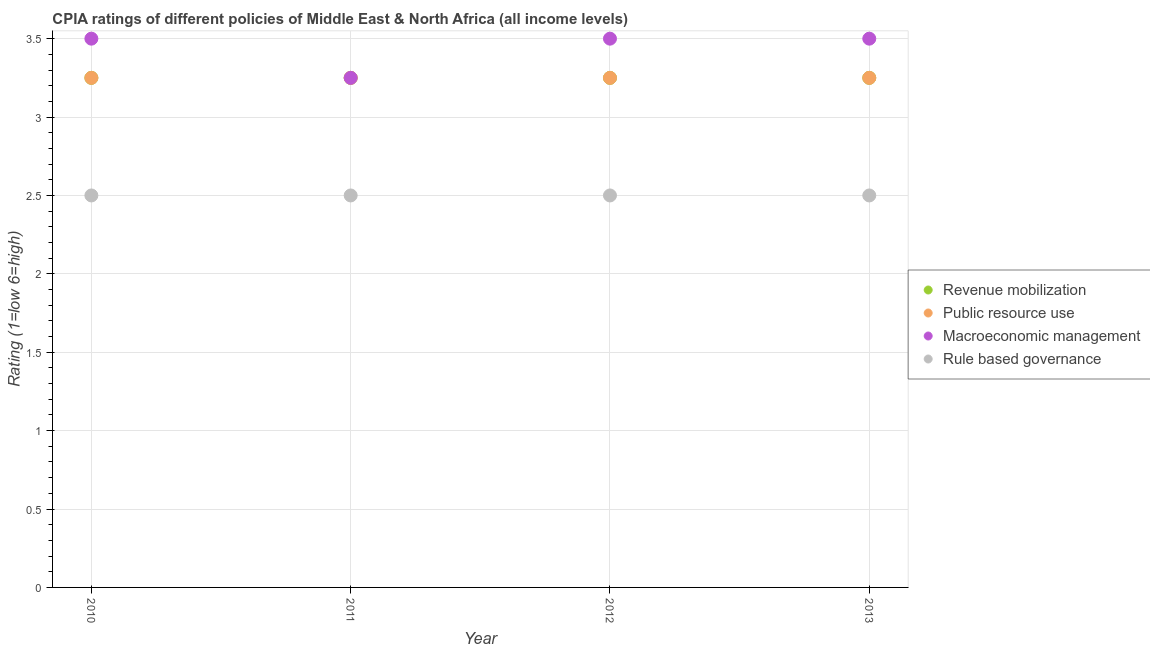Is the number of dotlines equal to the number of legend labels?
Offer a very short reply. Yes. What is the cpia rating of rule based governance in 2012?
Your answer should be compact. 2.5. Across all years, what is the maximum cpia rating of public resource use?
Your answer should be compact. 3.25. In which year was the cpia rating of revenue mobilization maximum?
Ensure brevity in your answer.  2010. In which year was the cpia rating of public resource use minimum?
Make the answer very short. 2010. What is the total cpia rating of rule based governance in the graph?
Offer a terse response. 10. What is the difference between the cpia rating of revenue mobilization in 2011 and that in 2012?
Offer a terse response. 0. What is the average cpia rating of macroeconomic management per year?
Make the answer very short. 3.44. In the year 2012, what is the difference between the cpia rating of rule based governance and cpia rating of macroeconomic management?
Your response must be concise. -1. Is the cpia rating of public resource use in 2010 less than that in 2012?
Give a very brief answer. No. Is the difference between the cpia rating of revenue mobilization in 2012 and 2013 greater than the difference between the cpia rating of macroeconomic management in 2012 and 2013?
Ensure brevity in your answer.  No. What is the difference between the highest and the second highest cpia rating of rule based governance?
Provide a succinct answer. 0. In how many years, is the cpia rating of rule based governance greater than the average cpia rating of rule based governance taken over all years?
Your response must be concise. 0. Is it the case that in every year, the sum of the cpia rating of revenue mobilization and cpia rating of public resource use is greater than the cpia rating of macroeconomic management?
Give a very brief answer. Yes. Does the cpia rating of public resource use monotonically increase over the years?
Make the answer very short. No. Is the cpia rating of macroeconomic management strictly less than the cpia rating of public resource use over the years?
Make the answer very short. No. Does the graph contain any zero values?
Offer a very short reply. No. Does the graph contain grids?
Ensure brevity in your answer.  Yes. What is the title of the graph?
Ensure brevity in your answer.  CPIA ratings of different policies of Middle East & North Africa (all income levels). Does "Macroeconomic management" appear as one of the legend labels in the graph?
Make the answer very short. Yes. What is the label or title of the X-axis?
Make the answer very short. Year. What is the Rating (1=low 6=high) in Public resource use in 2010?
Your answer should be very brief. 3.25. What is the Rating (1=low 6=high) in Rule based governance in 2010?
Offer a very short reply. 2.5. What is the Rating (1=low 6=high) of Public resource use in 2011?
Make the answer very short. 3.25. What is the Rating (1=low 6=high) in Macroeconomic management in 2011?
Provide a succinct answer. 3.25. What is the Rating (1=low 6=high) in Rule based governance in 2011?
Provide a short and direct response. 2.5. What is the Rating (1=low 6=high) of Public resource use in 2012?
Provide a succinct answer. 3.25. What is the Rating (1=low 6=high) in Macroeconomic management in 2012?
Provide a succinct answer. 3.5. What is the Rating (1=low 6=high) in Rule based governance in 2012?
Give a very brief answer. 2.5. What is the Rating (1=low 6=high) in Revenue mobilization in 2013?
Offer a terse response. 3.25. What is the Rating (1=low 6=high) of Rule based governance in 2013?
Your answer should be very brief. 2.5. Across all years, what is the maximum Rating (1=low 6=high) in Revenue mobilization?
Give a very brief answer. 3.25. Across all years, what is the maximum Rating (1=low 6=high) of Macroeconomic management?
Give a very brief answer. 3.5. Across all years, what is the minimum Rating (1=low 6=high) of Revenue mobilization?
Offer a very short reply. 3.25. Across all years, what is the minimum Rating (1=low 6=high) in Macroeconomic management?
Make the answer very short. 3.25. What is the total Rating (1=low 6=high) of Public resource use in the graph?
Provide a succinct answer. 13. What is the total Rating (1=low 6=high) in Macroeconomic management in the graph?
Your answer should be compact. 13.75. What is the difference between the Rating (1=low 6=high) in Revenue mobilization in 2010 and that in 2011?
Offer a very short reply. 0. What is the difference between the Rating (1=low 6=high) in Macroeconomic management in 2010 and that in 2011?
Make the answer very short. 0.25. What is the difference between the Rating (1=low 6=high) of Rule based governance in 2010 and that in 2011?
Keep it short and to the point. 0. What is the difference between the Rating (1=low 6=high) in Revenue mobilization in 2010 and that in 2012?
Ensure brevity in your answer.  0. What is the difference between the Rating (1=low 6=high) in Macroeconomic management in 2010 and that in 2012?
Ensure brevity in your answer.  0. What is the difference between the Rating (1=low 6=high) of Rule based governance in 2010 and that in 2012?
Ensure brevity in your answer.  0. What is the difference between the Rating (1=low 6=high) of Revenue mobilization in 2010 and that in 2013?
Offer a terse response. 0. What is the difference between the Rating (1=low 6=high) in Public resource use in 2010 and that in 2013?
Your answer should be very brief. 0. What is the difference between the Rating (1=low 6=high) of Macroeconomic management in 2010 and that in 2013?
Your answer should be compact. 0. What is the difference between the Rating (1=low 6=high) of Revenue mobilization in 2011 and that in 2012?
Offer a very short reply. 0. What is the difference between the Rating (1=low 6=high) in Public resource use in 2011 and that in 2012?
Offer a very short reply. 0. What is the difference between the Rating (1=low 6=high) of Revenue mobilization in 2011 and that in 2013?
Offer a very short reply. 0. What is the difference between the Rating (1=low 6=high) of Public resource use in 2011 and that in 2013?
Make the answer very short. 0. What is the difference between the Rating (1=low 6=high) of Rule based governance in 2011 and that in 2013?
Provide a short and direct response. 0. What is the difference between the Rating (1=low 6=high) of Revenue mobilization in 2012 and that in 2013?
Provide a short and direct response. 0. What is the difference between the Rating (1=low 6=high) in Macroeconomic management in 2012 and that in 2013?
Offer a terse response. 0. What is the difference between the Rating (1=low 6=high) in Public resource use in 2010 and the Rating (1=low 6=high) in Rule based governance in 2011?
Provide a short and direct response. 0.75. What is the difference between the Rating (1=low 6=high) of Macroeconomic management in 2010 and the Rating (1=low 6=high) of Rule based governance in 2011?
Your response must be concise. 1. What is the difference between the Rating (1=low 6=high) of Revenue mobilization in 2010 and the Rating (1=low 6=high) of Rule based governance in 2012?
Make the answer very short. 0.75. What is the difference between the Rating (1=low 6=high) in Public resource use in 2010 and the Rating (1=low 6=high) in Rule based governance in 2012?
Ensure brevity in your answer.  0.75. What is the difference between the Rating (1=low 6=high) of Revenue mobilization in 2010 and the Rating (1=low 6=high) of Macroeconomic management in 2013?
Offer a very short reply. -0.25. What is the difference between the Rating (1=low 6=high) of Public resource use in 2010 and the Rating (1=low 6=high) of Macroeconomic management in 2013?
Provide a succinct answer. -0.25. What is the difference between the Rating (1=low 6=high) in Public resource use in 2010 and the Rating (1=low 6=high) in Rule based governance in 2013?
Keep it short and to the point. 0.75. What is the difference between the Rating (1=low 6=high) in Revenue mobilization in 2011 and the Rating (1=low 6=high) in Macroeconomic management in 2012?
Give a very brief answer. -0.25. What is the difference between the Rating (1=low 6=high) of Revenue mobilization in 2011 and the Rating (1=low 6=high) of Rule based governance in 2012?
Keep it short and to the point. 0.75. What is the difference between the Rating (1=low 6=high) of Public resource use in 2011 and the Rating (1=low 6=high) of Macroeconomic management in 2012?
Ensure brevity in your answer.  -0.25. What is the difference between the Rating (1=low 6=high) in Macroeconomic management in 2011 and the Rating (1=low 6=high) in Rule based governance in 2012?
Make the answer very short. 0.75. What is the difference between the Rating (1=low 6=high) of Revenue mobilization in 2011 and the Rating (1=low 6=high) of Rule based governance in 2013?
Offer a terse response. 0.75. What is the difference between the Rating (1=low 6=high) of Public resource use in 2011 and the Rating (1=low 6=high) of Macroeconomic management in 2013?
Make the answer very short. -0.25. What is the difference between the Rating (1=low 6=high) of Public resource use in 2011 and the Rating (1=low 6=high) of Rule based governance in 2013?
Provide a short and direct response. 0.75. What is the difference between the Rating (1=low 6=high) in Revenue mobilization in 2012 and the Rating (1=low 6=high) in Public resource use in 2013?
Keep it short and to the point. 0. What is the difference between the Rating (1=low 6=high) of Revenue mobilization in 2012 and the Rating (1=low 6=high) of Rule based governance in 2013?
Provide a succinct answer. 0.75. What is the difference between the Rating (1=low 6=high) in Public resource use in 2012 and the Rating (1=low 6=high) in Rule based governance in 2013?
Give a very brief answer. 0.75. What is the difference between the Rating (1=low 6=high) of Macroeconomic management in 2012 and the Rating (1=low 6=high) of Rule based governance in 2013?
Give a very brief answer. 1. What is the average Rating (1=low 6=high) of Revenue mobilization per year?
Give a very brief answer. 3.25. What is the average Rating (1=low 6=high) in Macroeconomic management per year?
Give a very brief answer. 3.44. In the year 2010, what is the difference between the Rating (1=low 6=high) of Revenue mobilization and Rating (1=low 6=high) of Macroeconomic management?
Your answer should be very brief. -0.25. In the year 2010, what is the difference between the Rating (1=low 6=high) of Public resource use and Rating (1=low 6=high) of Macroeconomic management?
Your answer should be very brief. -0.25. In the year 2011, what is the difference between the Rating (1=low 6=high) in Revenue mobilization and Rating (1=low 6=high) in Macroeconomic management?
Give a very brief answer. 0. In the year 2011, what is the difference between the Rating (1=low 6=high) in Revenue mobilization and Rating (1=low 6=high) in Rule based governance?
Your response must be concise. 0.75. In the year 2011, what is the difference between the Rating (1=low 6=high) in Public resource use and Rating (1=low 6=high) in Macroeconomic management?
Make the answer very short. 0. In the year 2011, what is the difference between the Rating (1=low 6=high) of Public resource use and Rating (1=low 6=high) of Rule based governance?
Offer a very short reply. 0.75. In the year 2011, what is the difference between the Rating (1=low 6=high) of Macroeconomic management and Rating (1=low 6=high) of Rule based governance?
Offer a terse response. 0.75. In the year 2012, what is the difference between the Rating (1=low 6=high) of Public resource use and Rating (1=low 6=high) of Macroeconomic management?
Offer a very short reply. -0.25. In the year 2013, what is the difference between the Rating (1=low 6=high) in Revenue mobilization and Rating (1=low 6=high) in Public resource use?
Keep it short and to the point. 0. In the year 2013, what is the difference between the Rating (1=low 6=high) of Public resource use and Rating (1=low 6=high) of Rule based governance?
Your answer should be compact. 0.75. In the year 2013, what is the difference between the Rating (1=low 6=high) in Macroeconomic management and Rating (1=low 6=high) in Rule based governance?
Ensure brevity in your answer.  1. What is the ratio of the Rating (1=low 6=high) in Revenue mobilization in 2010 to that in 2011?
Provide a short and direct response. 1. What is the ratio of the Rating (1=low 6=high) in Macroeconomic management in 2010 to that in 2011?
Ensure brevity in your answer.  1.08. What is the ratio of the Rating (1=low 6=high) of Macroeconomic management in 2010 to that in 2012?
Give a very brief answer. 1. What is the ratio of the Rating (1=low 6=high) of Public resource use in 2010 to that in 2013?
Offer a terse response. 1. What is the ratio of the Rating (1=low 6=high) in Rule based governance in 2010 to that in 2013?
Offer a very short reply. 1. What is the ratio of the Rating (1=low 6=high) of Revenue mobilization in 2011 to that in 2012?
Ensure brevity in your answer.  1. What is the ratio of the Rating (1=low 6=high) of Macroeconomic management in 2011 to that in 2012?
Make the answer very short. 0.93. What is the ratio of the Rating (1=low 6=high) in Revenue mobilization in 2011 to that in 2013?
Ensure brevity in your answer.  1. What is the ratio of the Rating (1=low 6=high) of Public resource use in 2011 to that in 2013?
Provide a succinct answer. 1. What is the ratio of the Rating (1=low 6=high) in Macroeconomic management in 2011 to that in 2013?
Your answer should be compact. 0.93. What is the ratio of the Rating (1=low 6=high) in Macroeconomic management in 2012 to that in 2013?
Your answer should be very brief. 1. What is the difference between the highest and the second highest Rating (1=low 6=high) of Revenue mobilization?
Offer a terse response. 0. What is the difference between the highest and the lowest Rating (1=low 6=high) in Public resource use?
Make the answer very short. 0. What is the difference between the highest and the lowest Rating (1=low 6=high) of Macroeconomic management?
Offer a terse response. 0.25. What is the difference between the highest and the lowest Rating (1=low 6=high) in Rule based governance?
Your answer should be very brief. 0. 